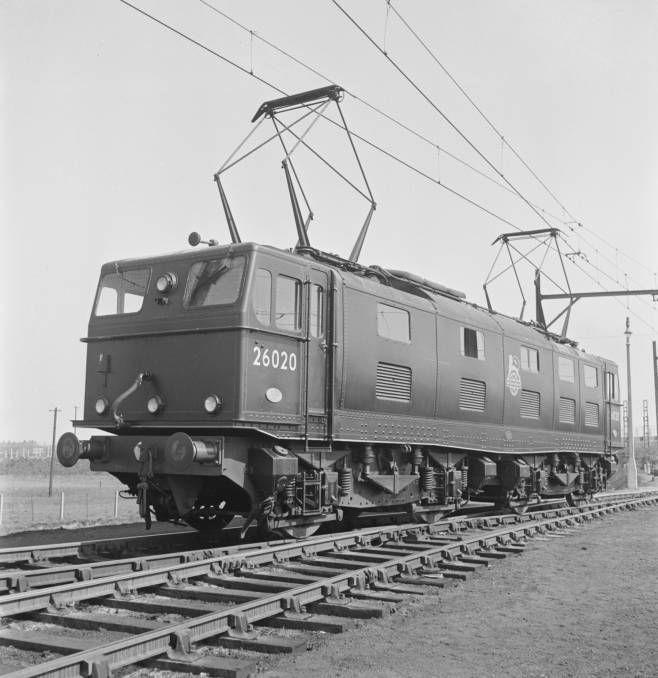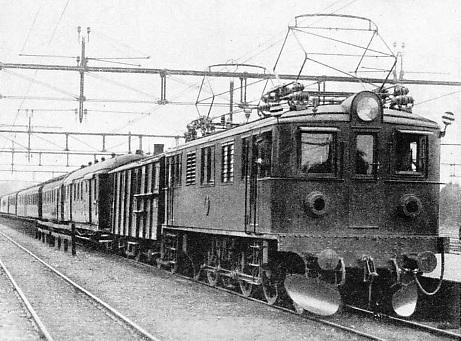The first image is the image on the left, the second image is the image on the right. Analyze the images presented: Is the assertion "The two trains pictured head in opposite directions, and the train on the right has three windows across the front." valid? Answer yes or no. Yes. The first image is the image on the left, the second image is the image on the right. Analyze the images presented: Is the assertion "There are two trains facing opposite directions, in black and white." valid? Answer yes or no. Yes. 